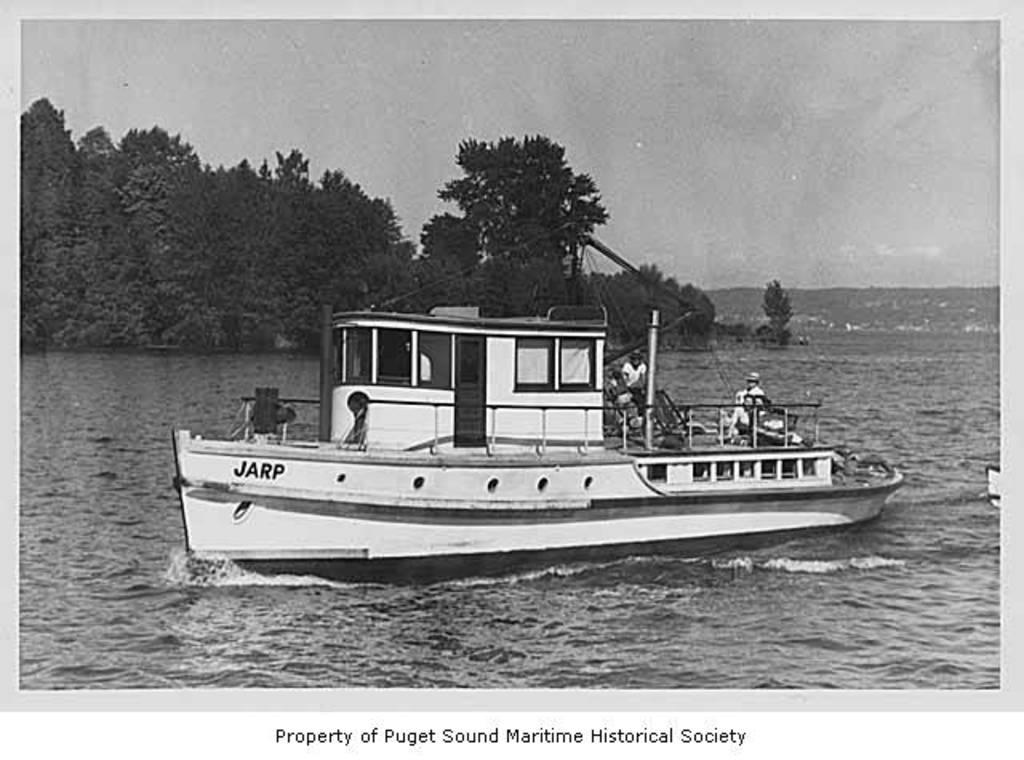What is the main subject of the image? The main subject of the image is a paper. What is depicted on the paper? The paper depicts a sky, clouds, trees, a hill, water, and a boat. Are there any people in the image? Yes, there are people sitting on the boat. How many gold coins can be seen on the boat in the image? There are no gold coins present in the image; the boat is depicted on the paper, and no coins are visible. 